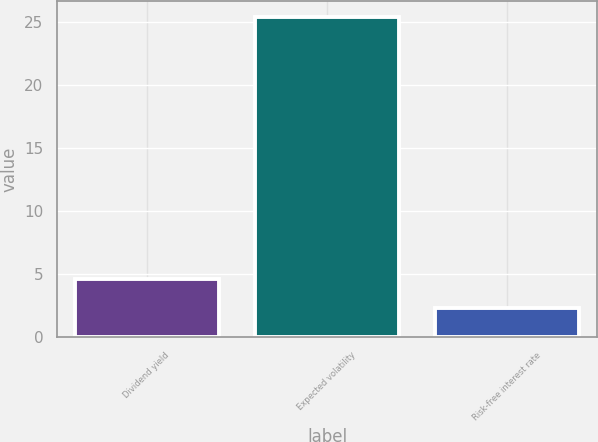Convert chart. <chart><loc_0><loc_0><loc_500><loc_500><bar_chart><fcel>Dividend yield<fcel>Expected volatility<fcel>Risk-free interest rate<nl><fcel>4.61<fcel>25.4<fcel>2.3<nl></chart> 